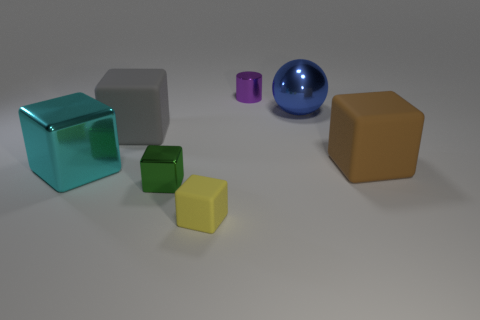There is a purple shiny thing that is the same size as the yellow rubber object; what shape is it?
Provide a succinct answer. Cylinder. How many other things are there of the same color as the big shiny sphere?
Give a very brief answer. 0. What is the material of the large cyan thing?
Keep it short and to the point. Metal. What number of other objects are there of the same material as the brown cube?
Your answer should be very brief. 2. What is the size of the thing that is both behind the large metallic cube and on the left side of the small matte block?
Keep it short and to the point. Large. The matte thing in front of the rubber object that is right of the purple object is what shape?
Offer a very short reply. Cube. Are there any other things that have the same shape as the large blue metallic thing?
Keep it short and to the point. No. Are there the same number of large cyan blocks that are behind the large gray rubber block and large gray matte balls?
Give a very brief answer. Yes. There is a rubber thing that is both behind the green thing and on the left side of the tiny purple shiny object; what is its color?
Your response must be concise. Gray. There is a large metallic object that is behind the large gray cube; what number of large cubes are left of it?
Your answer should be very brief. 2. 